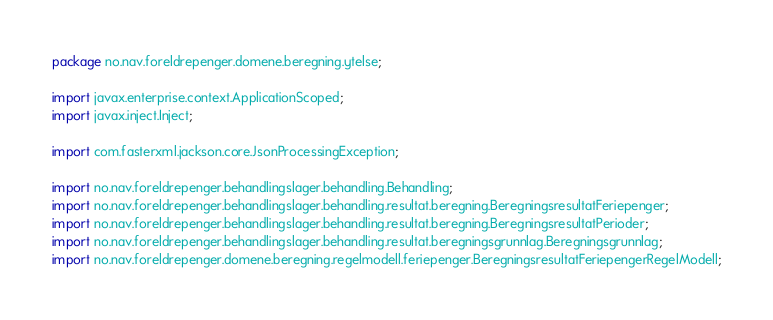<code> <loc_0><loc_0><loc_500><loc_500><_Java_>package no.nav.foreldrepenger.domene.beregning.ytelse;

import javax.enterprise.context.ApplicationScoped;
import javax.inject.Inject;

import com.fasterxml.jackson.core.JsonProcessingException;

import no.nav.foreldrepenger.behandlingslager.behandling.Behandling;
import no.nav.foreldrepenger.behandlingslager.behandling.resultat.beregning.BeregningsresultatFeriepenger;
import no.nav.foreldrepenger.behandlingslager.behandling.resultat.beregning.BeregningsresultatPerioder;
import no.nav.foreldrepenger.behandlingslager.behandling.resultat.beregningsgrunnlag.Beregningsgrunnlag;
import no.nav.foreldrepenger.domene.beregning.regelmodell.feriepenger.BeregningsresultatFeriepengerRegelModell;</code> 